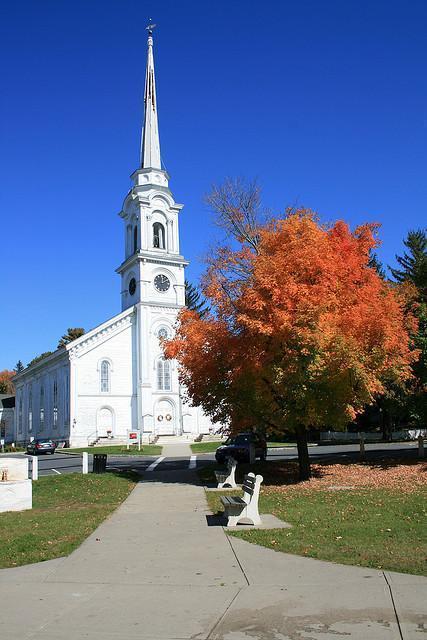How many people are entering the train?
Give a very brief answer. 0. 